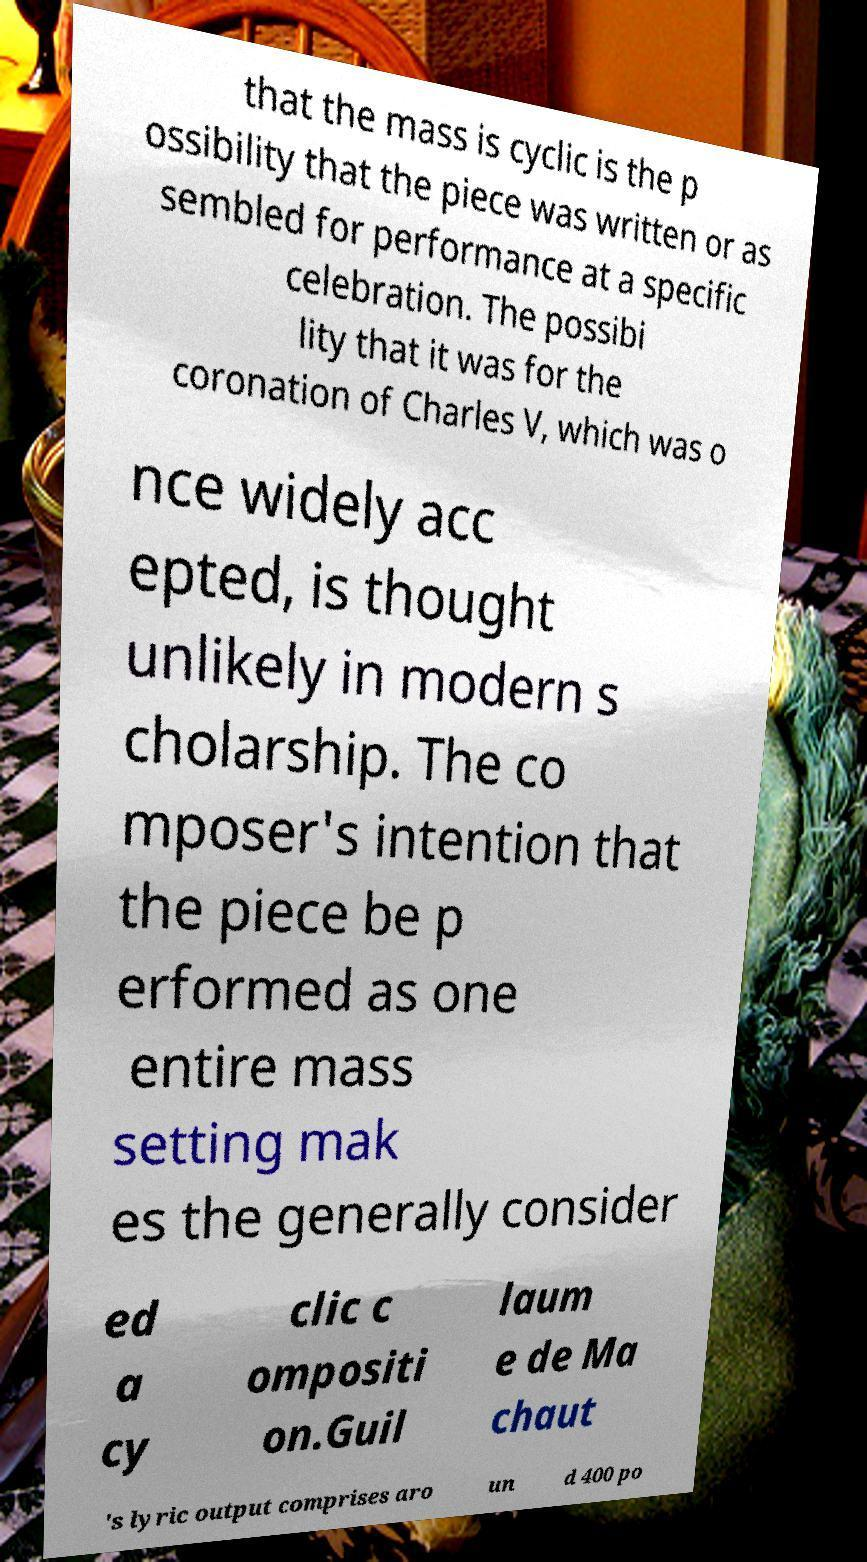For documentation purposes, I need the text within this image transcribed. Could you provide that? that the mass is cyclic is the p ossibility that the piece was written or as sembled for performance at a specific celebration. The possibi lity that it was for the coronation of Charles V, which was o nce widely acc epted, is thought unlikely in modern s cholarship. The co mposer's intention that the piece be p erformed as one entire mass setting mak es the generally consider ed a cy clic c ompositi on.Guil laum e de Ma chaut 's lyric output comprises aro un d 400 po 